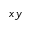Convert formula to latex. <formula><loc_0><loc_0><loc_500><loc_500>x y</formula> 